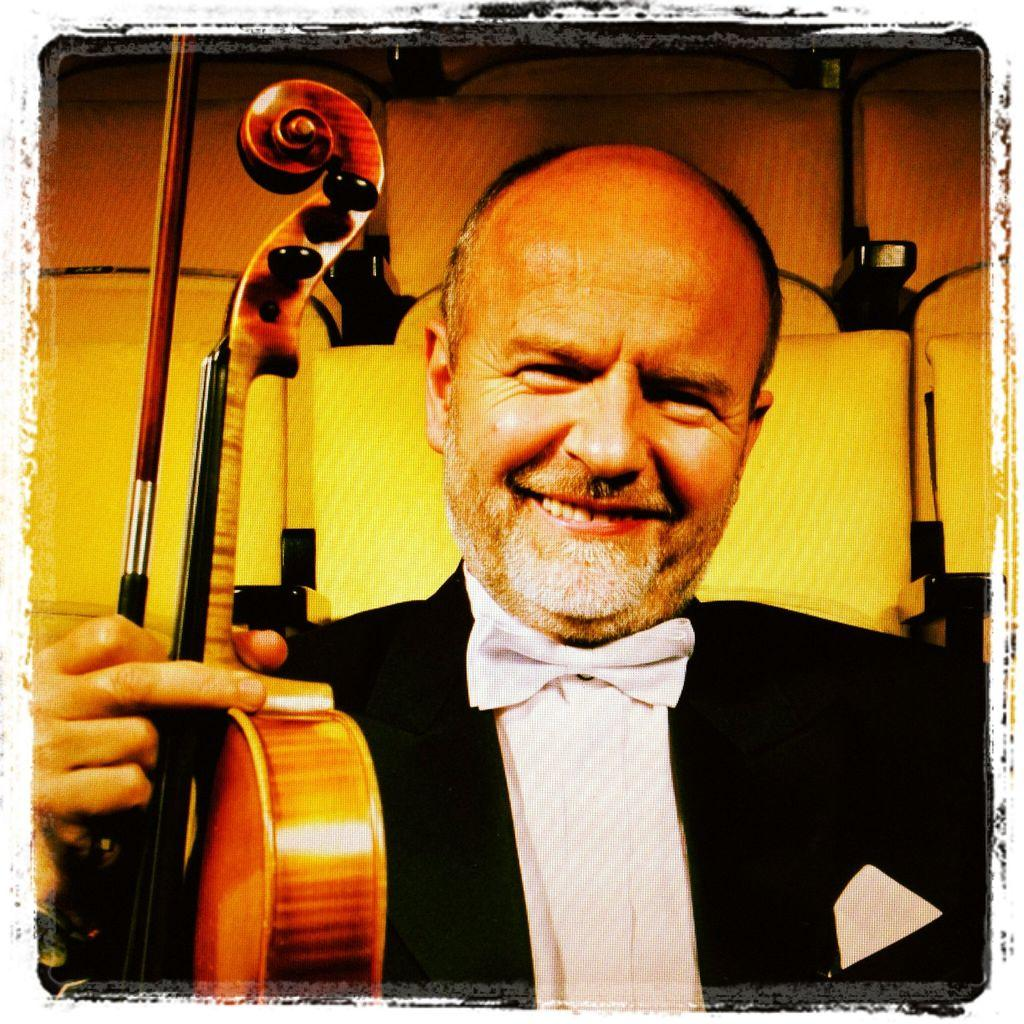What is the main subject of the image? The main subject of the image is a man. What is the man holding in the image? The man is holding a violin in the image. What is the man's facial expression in the image? The man is smiling in the image. What type of button is the man wearing on his shirt in the image? There is no button mentioned or visible in the image; the man is holding a violin. How much debt does the man have, as depicted in the image? There is no information about the man's debt in the image; it only shows him holding a violin and smiling. 